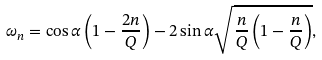<formula> <loc_0><loc_0><loc_500><loc_500>\omega _ { n } = \cos \alpha \left ( 1 - \frac { 2 n } { Q } \right ) - 2 \sin \alpha \sqrt { \frac { n } { Q } \left ( 1 - \frac { n } { Q } \right ) } ,</formula> 